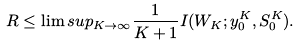Convert formula to latex. <formula><loc_0><loc_0><loc_500><loc_500>R \leq \lim s u p _ { K \rightarrow \infty } \frac { 1 } { K + 1 } I ( W _ { K } ; y _ { 0 } ^ { K } , S _ { 0 } ^ { K } ) .</formula> 